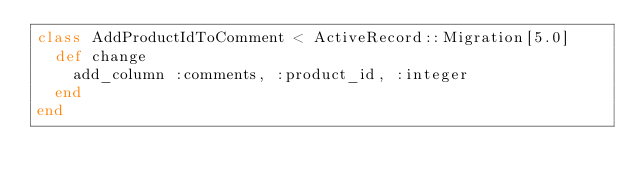<code> <loc_0><loc_0><loc_500><loc_500><_Ruby_>class AddProductIdToComment < ActiveRecord::Migration[5.0]
  def change
    add_column :comments, :product_id, :integer
  end
end
</code> 